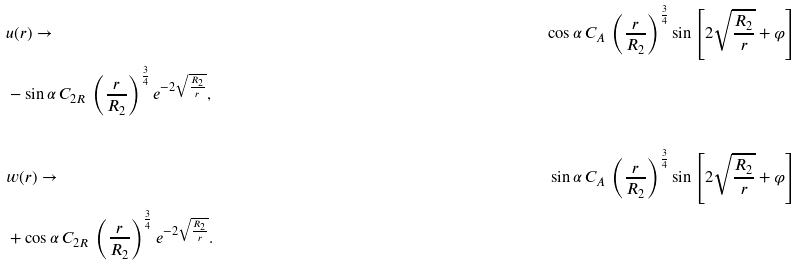Convert formula to latex. <formula><loc_0><loc_0><loc_500><loc_500>& u ( r ) \to & \cos \alpha \, C _ { A } \, \left ( \frac { r } { R _ { 2 } } \right ) ^ { \frac { 3 } { 4 } } \sin \left [ 2 \sqrt { \frac { R _ { 2 } } { r } } + \varphi \right ] \\ & - \sin \alpha \, C _ { 2 R } \, \left ( \frac { r } { R _ { 2 } } \right ) ^ { \frac { 3 } { 4 } } e ^ { - 2 \sqrt { \frac { R _ { 2 } } { r } } } , \\ & \\ & w ( r ) \to & \sin \alpha \, C _ { A } \, \left ( \frac { r } { R _ { 2 } } \right ) ^ { \frac { 3 } { 4 } } \sin \left [ 2 \sqrt { \frac { R _ { 2 } } { r } } + \varphi \right ] \\ & + \cos \alpha \, C _ { 2 R } \, \left ( \frac { r } { R _ { 2 } } \right ) ^ { \frac { 3 } { 4 } } e ^ { - 2 \sqrt { \frac { R _ { 2 } } { r } } } .</formula> 